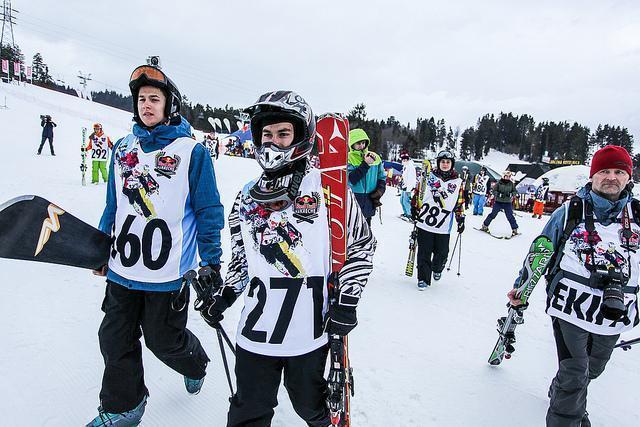WHat kind of competition is taking place?
Choose the right answer and clarify with the format: 'Answer: answer
Rationale: rationale.'
Options: Snowball, skiing, ice, snowboard. Answer: skiing.
Rationale: The people are all carrying snowboards. 